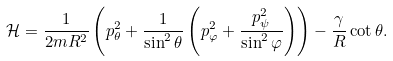<formula> <loc_0><loc_0><loc_500><loc_500>\mathcal { H } = \frac { 1 } { 2 m R ^ { 2 } } \left ( p _ { \theta } ^ { 2 } + \frac { 1 } { \sin ^ { 2 } \theta } \left ( p ^ { 2 } _ { \varphi } + \frac { p _ { \psi } ^ { 2 } } { \sin ^ { 2 } { \varphi } } \right ) \right ) - \frac { \gamma } { R } \cot \theta .</formula> 